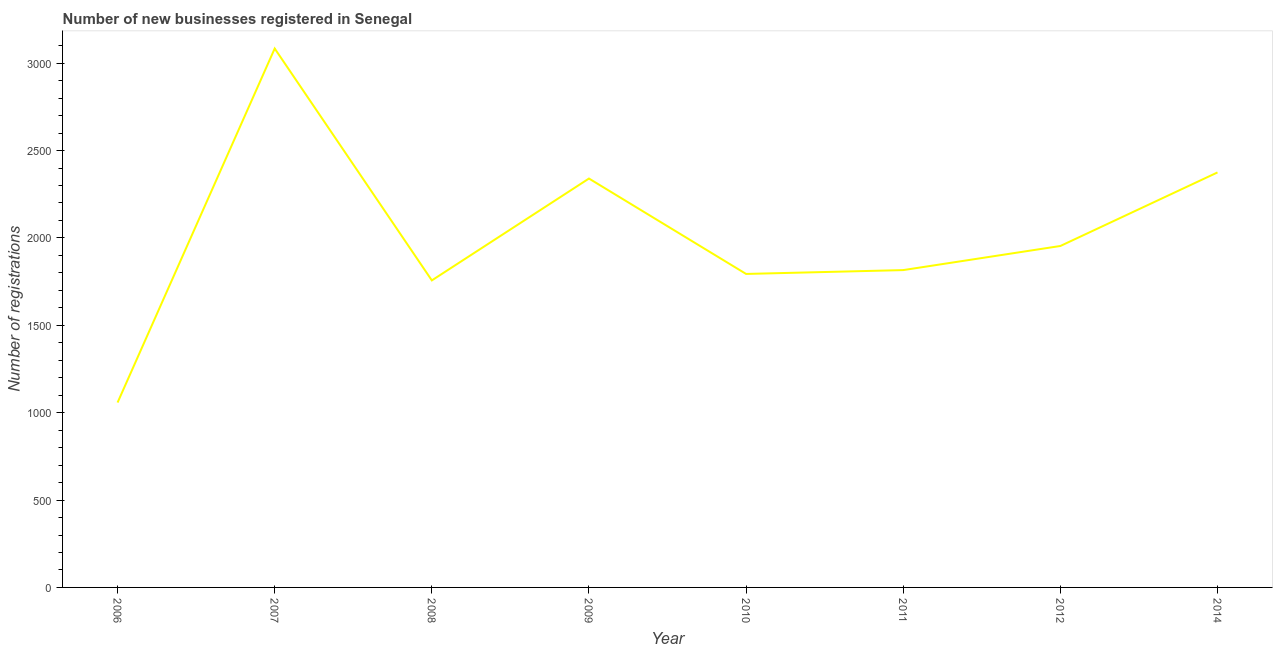What is the number of new business registrations in 2010?
Ensure brevity in your answer.  1794. Across all years, what is the maximum number of new business registrations?
Ensure brevity in your answer.  3084. Across all years, what is the minimum number of new business registrations?
Keep it short and to the point. 1058. In which year was the number of new business registrations maximum?
Offer a terse response. 2007. What is the sum of the number of new business registrations?
Offer a very short reply. 1.62e+04. What is the difference between the number of new business registrations in 2009 and 2014?
Your answer should be compact. -35. What is the average number of new business registrations per year?
Your response must be concise. 2022.25. What is the median number of new business registrations?
Provide a succinct answer. 1885. In how many years, is the number of new business registrations greater than 900 ?
Offer a terse response. 8. Do a majority of the years between 2011 and 2014 (inclusive) have number of new business registrations greater than 1500 ?
Offer a very short reply. Yes. What is the ratio of the number of new business registrations in 2006 to that in 2010?
Offer a very short reply. 0.59. Is the number of new business registrations in 2008 less than that in 2011?
Make the answer very short. Yes. What is the difference between the highest and the second highest number of new business registrations?
Provide a short and direct response. 709. Is the sum of the number of new business registrations in 2009 and 2014 greater than the maximum number of new business registrations across all years?
Your answer should be very brief. Yes. What is the difference between the highest and the lowest number of new business registrations?
Provide a succinct answer. 2026. Does the number of new business registrations monotonically increase over the years?
Provide a succinct answer. No. How many lines are there?
Your answer should be very brief. 1. How many years are there in the graph?
Give a very brief answer. 8. Are the values on the major ticks of Y-axis written in scientific E-notation?
Offer a terse response. No. Does the graph contain any zero values?
Make the answer very short. No. What is the title of the graph?
Keep it short and to the point. Number of new businesses registered in Senegal. What is the label or title of the Y-axis?
Ensure brevity in your answer.  Number of registrations. What is the Number of registrations of 2006?
Your response must be concise. 1058. What is the Number of registrations of 2007?
Give a very brief answer. 3084. What is the Number of registrations of 2008?
Your answer should be compact. 1757. What is the Number of registrations in 2009?
Offer a very short reply. 2340. What is the Number of registrations in 2010?
Make the answer very short. 1794. What is the Number of registrations in 2011?
Ensure brevity in your answer.  1816. What is the Number of registrations of 2012?
Provide a succinct answer. 1954. What is the Number of registrations in 2014?
Make the answer very short. 2375. What is the difference between the Number of registrations in 2006 and 2007?
Your answer should be compact. -2026. What is the difference between the Number of registrations in 2006 and 2008?
Keep it short and to the point. -699. What is the difference between the Number of registrations in 2006 and 2009?
Your response must be concise. -1282. What is the difference between the Number of registrations in 2006 and 2010?
Keep it short and to the point. -736. What is the difference between the Number of registrations in 2006 and 2011?
Make the answer very short. -758. What is the difference between the Number of registrations in 2006 and 2012?
Keep it short and to the point. -896. What is the difference between the Number of registrations in 2006 and 2014?
Make the answer very short. -1317. What is the difference between the Number of registrations in 2007 and 2008?
Ensure brevity in your answer.  1327. What is the difference between the Number of registrations in 2007 and 2009?
Provide a succinct answer. 744. What is the difference between the Number of registrations in 2007 and 2010?
Give a very brief answer. 1290. What is the difference between the Number of registrations in 2007 and 2011?
Your response must be concise. 1268. What is the difference between the Number of registrations in 2007 and 2012?
Provide a short and direct response. 1130. What is the difference between the Number of registrations in 2007 and 2014?
Make the answer very short. 709. What is the difference between the Number of registrations in 2008 and 2009?
Ensure brevity in your answer.  -583. What is the difference between the Number of registrations in 2008 and 2010?
Your answer should be compact. -37. What is the difference between the Number of registrations in 2008 and 2011?
Provide a short and direct response. -59. What is the difference between the Number of registrations in 2008 and 2012?
Offer a very short reply. -197. What is the difference between the Number of registrations in 2008 and 2014?
Provide a succinct answer. -618. What is the difference between the Number of registrations in 2009 and 2010?
Keep it short and to the point. 546. What is the difference between the Number of registrations in 2009 and 2011?
Your answer should be very brief. 524. What is the difference between the Number of registrations in 2009 and 2012?
Offer a terse response. 386. What is the difference between the Number of registrations in 2009 and 2014?
Your answer should be compact. -35. What is the difference between the Number of registrations in 2010 and 2012?
Make the answer very short. -160. What is the difference between the Number of registrations in 2010 and 2014?
Offer a very short reply. -581. What is the difference between the Number of registrations in 2011 and 2012?
Give a very brief answer. -138. What is the difference between the Number of registrations in 2011 and 2014?
Your answer should be very brief. -559. What is the difference between the Number of registrations in 2012 and 2014?
Ensure brevity in your answer.  -421. What is the ratio of the Number of registrations in 2006 to that in 2007?
Offer a terse response. 0.34. What is the ratio of the Number of registrations in 2006 to that in 2008?
Give a very brief answer. 0.6. What is the ratio of the Number of registrations in 2006 to that in 2009?
Your answer should be compact. 0.45. What is the ratio of the Number of registrations in 2006 to that in 2010?
Ensure brevity in your answer.  0.59. What is the ratio of the Number of registrations in 2006 to that in 2011?
Give a very brief answer. 0.58. What is the ratio of the Number of registrations in 2006 to that in 2012?
Your answer should be very brief. 0.54. What is the ratio of the Number of registrations in 2006 to that in 2014?
Your response must be concise. 0.45. What is the ratio of the Number of registrations in 2007 to that in 2008?
Give a very brief answer. 1.75. What is the ratio of the Number of registrations in 2007 to that in 2009?
Ensure brevity in your answer.  1.32. What is the ratio of the Number of registrations in 2007 to that in 2010?
Make the answer very short. 1.72. What is the ratio of the Number of registrations in 2007 to that in 2011?
Give a very brief answer. 1.7. What is the ratio of the Number of registrations in 2007 to that in 2012?
Provide a succinct answer. 1.58. What is the ratio of the Number of registrations in 2007 to that in 2014?
Your response must be concise. 1.3. What is the ratio of the Number of registrations in 2008 to that in 2009?
Your response must be concise. 0.75. What is the ratio of the Number of registrations in 2008 to that in 2010?
Your answer should be very brief. 0.98. What is the ratio of the Number of registrations in 2008 to that in 2012?
Make the answer very short. 0.9. What is the ratio of the Number of registrations in 2008 to that in 2014?
Offer a terse response. 0.74. What is the ratio of the Number of registrations in 2009 to that in 2010?
Your answer should be compact. 1.3. What is the ratio of the Number of registrations in 2009 to that in 2011?
Provide a succinct answer. 1.29. What is the ratio of the Number of registrations in 2009 to that in 2012?
Make the answer very short. 1.2. What is the ratio of the Number of registrations in 2009 to that in 2014?
Offer a very short reply. 0.98. What is the ratio of the Number of registrations in 2010 to that in 2011?
Keep it short and to the point. 0.99. What is the ratio of the Number of registrations in 2010 to that in 2012?
Give a very brief answer. 0.92. What is the ratio of the Number of registrations in 2010 to that in 2014?
Provide a short and direct response. 0.76. What is the ratio of the Number of registrations in 2011 to that in 2012?
Make the answer very short. 0.93. What is the ratio of the Number of registrations in 2011 to that in 2014?
Provide a succinct answer. 0.77. What is the ratio of the Number of registrations in 2012 to that in 2014?
Offer a very short reply. 0.82. 